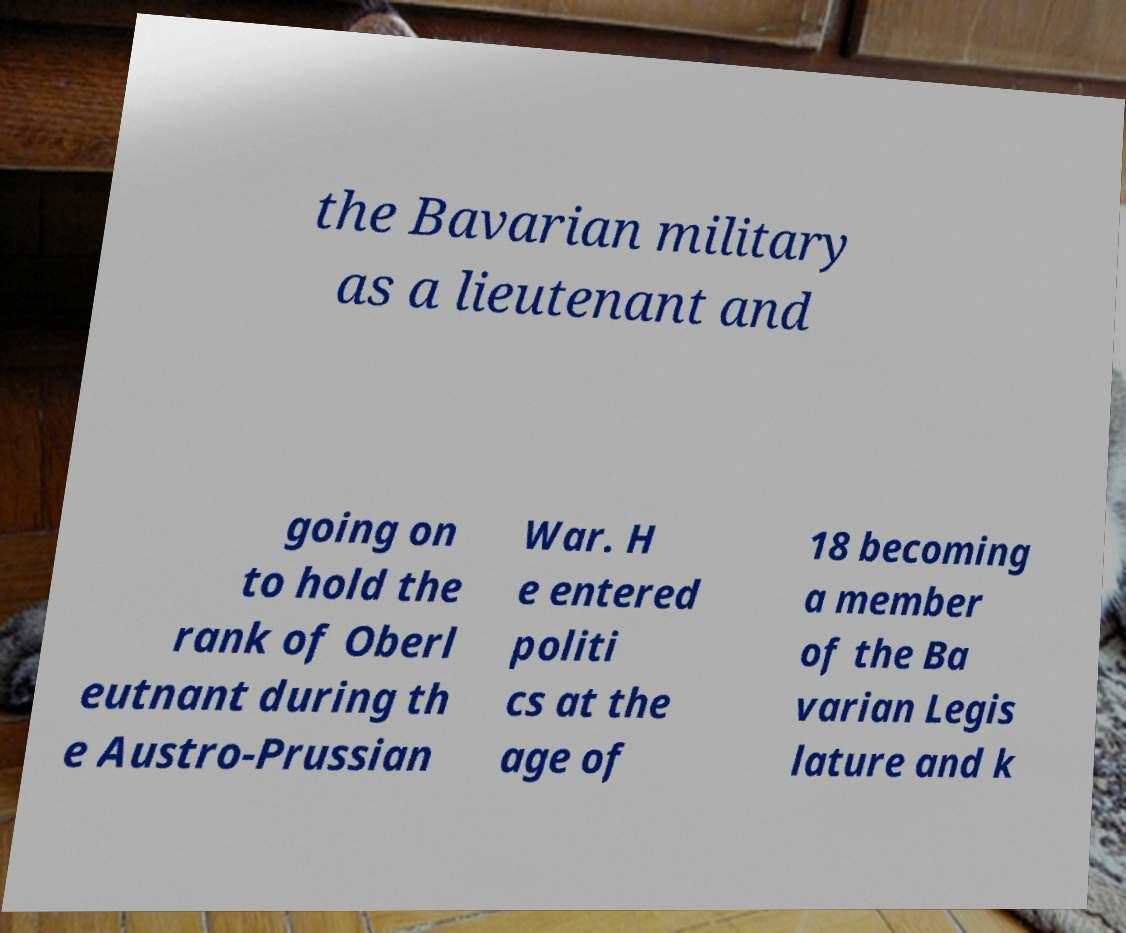Can you accurately transcribe the text from the provided image for me? the Bavarian military as a lieutenant and going on to hold the rank of Oberl eutnant during th e Austro-Prussian War. H e entered politi cs at the age of 18 becoming a member of the Ba varian Legis lature and k 